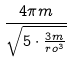Convert formula to latex. <formula><loc_0><loc_0><loc_500><loc_500>\frac { 4 \pi m } { \sqrt { 5 \cdot \frac { 3 m } { r o ^ { 3 } } } }</formula> 